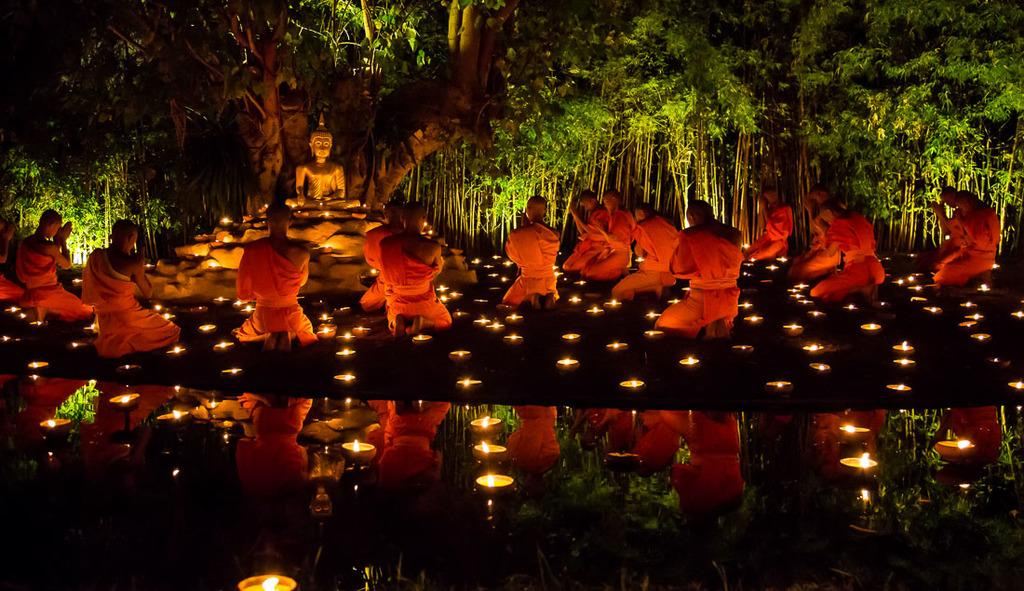How many people are in the image? There are persons in the image, but the exact number is not specified. What objects can be seen in the image besides the persons? There are candles and a sculpture in the image. What is the nature of the reflection at the bottom of the image? The bottom of the image has a reflection. What can be seen in the background of the image? There are trees in the background of the image. What type of glue is being used to attach the mist to the partner in the image? There is no mist, glue, or partner present in the image. 